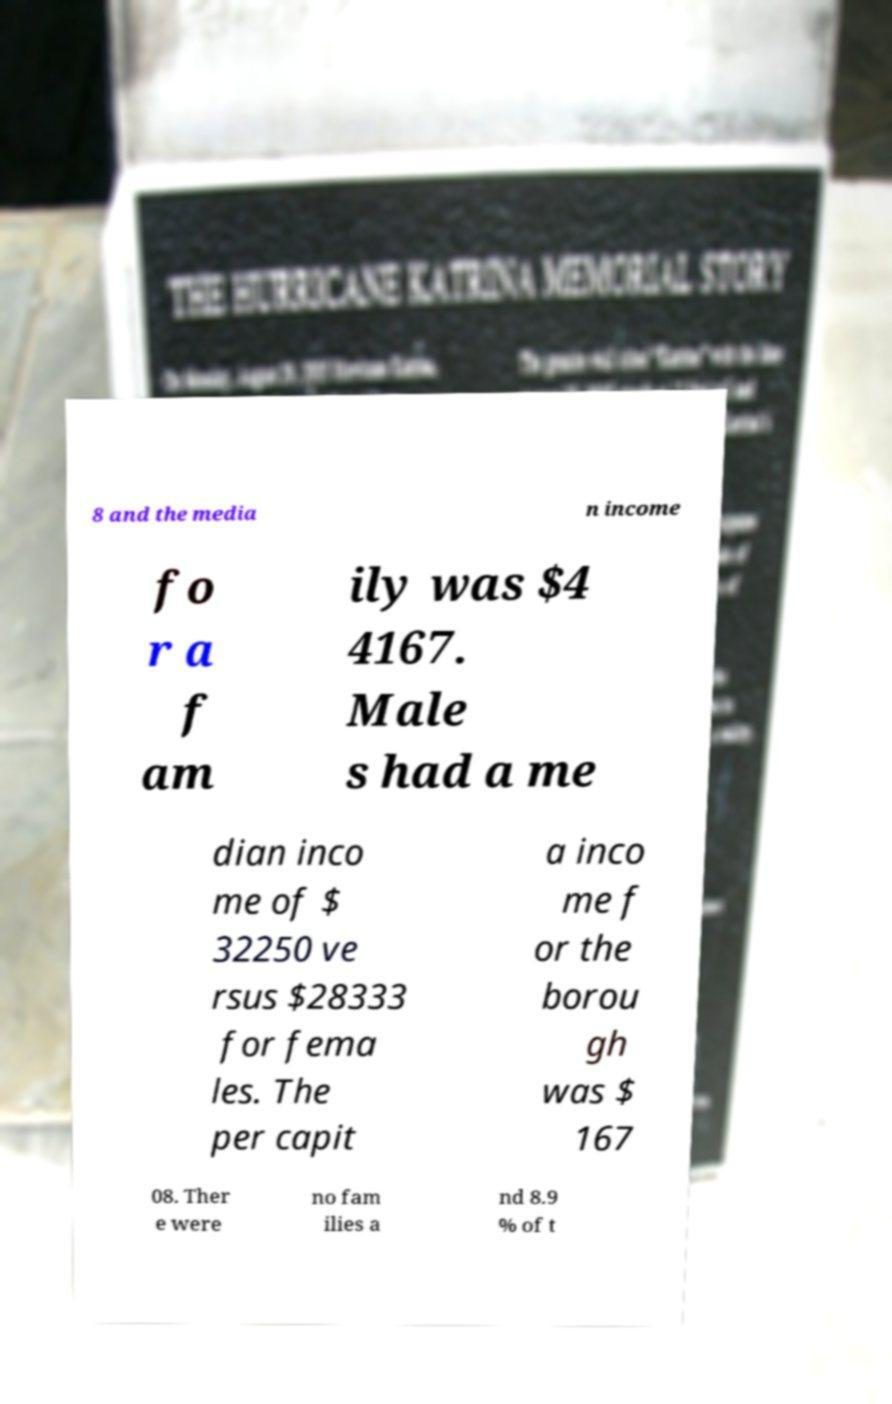Please identify and transcribe the text found in this image. 8 and the media n income fo r a f am ily was $4 4167. Male s had a me dian inco me of $ 32250 ve rsus $28333 for fema les. The per capit a inco me f or the borou gh was $ 167 08. Ther e were no fam ilies a nd 8.9 % of t 